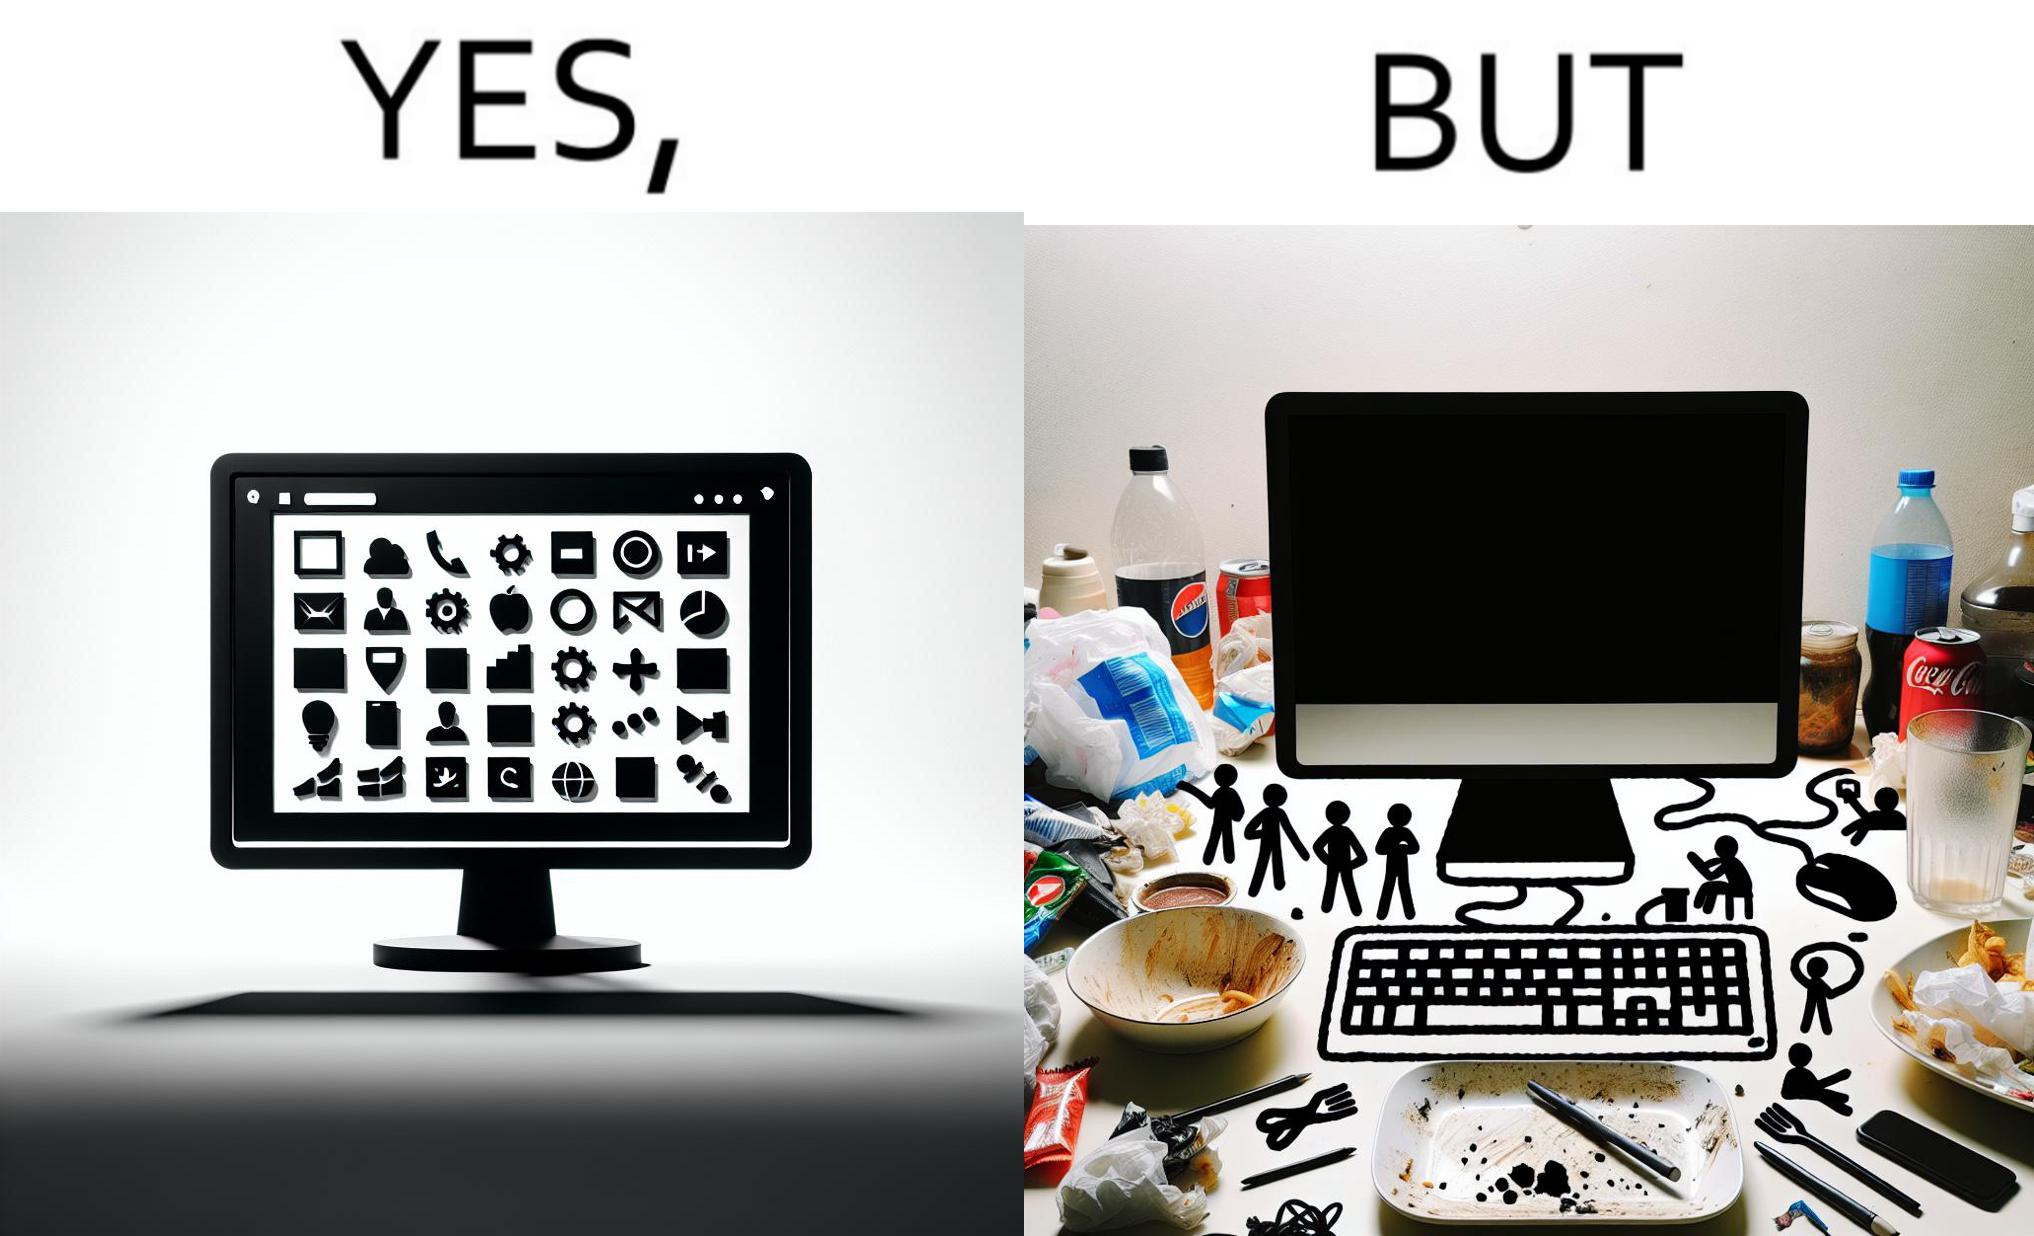What is shown in this image? The image is ironical, as the folder icons on the desktop screen are very neatly arranged, while the person using the computer has littered the table with used food packets, dirty plates, and wrappers. 